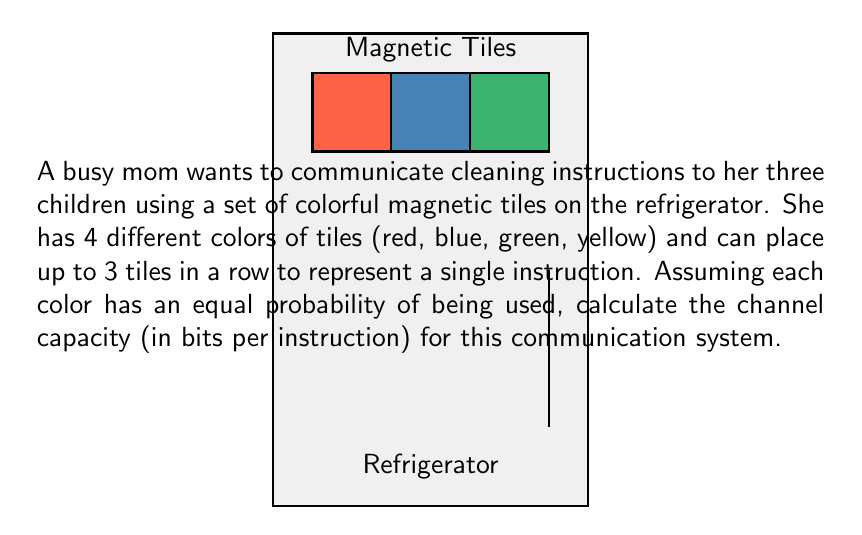Help me with this question. To calculate the channel capacity, we need to determine the maximum amount of information that can be transmitted per instruction. Let's approach this step-by-step:

1) First, we need to calculate the number of possible instructions:
   - We have 4 colors and 3 positions
   - For each position, we have 4 choices
   - Total number of possibilities = $4 \times 4 \times 4 = 4^3 = 64$

2) The channel capacity is given by the maximum entropy of the system. Since all colors have equal probability, this is achieved when all possible instructions are equally likely.

3) The entropy of a system with $n$ equally likely outcomes is given by:
   $H = \log_2(n)$ bits

4) In our case, $n = 64$, so:
   $H = \log_2(64) = 6$ bits

5) This means each instruction can carry up to 6 bits of information.

6) The channel capacity is thus 6 bits per instruction.

Therefore, the channel capacity for communicating cleaning instructions using this system is 6 bits per instruction.
Answer: 6 bits per instruction 